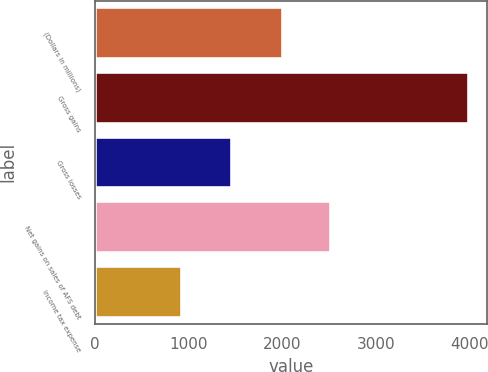<chart> <loc_0><loc_0><loc_500><loc_500><bar_chart><fcel>(Dollars in millions)<fcel>Gross gains<fcel>Gross losses<fcel>Net gains on sales of AFS debt<fcel>Income tax expense<nl><fcel>2010<fcel>3995<fcel>1469<fcel>2526<fcel>935<nl></chart> 